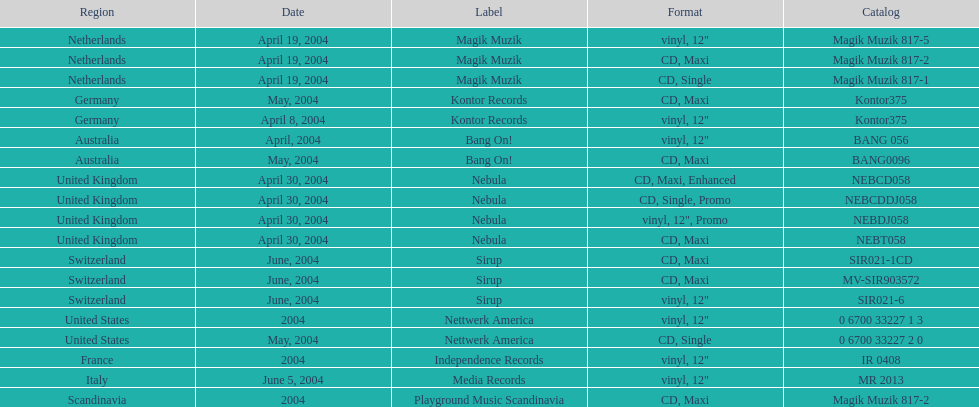Which area is mentioned first? Netherlands. 